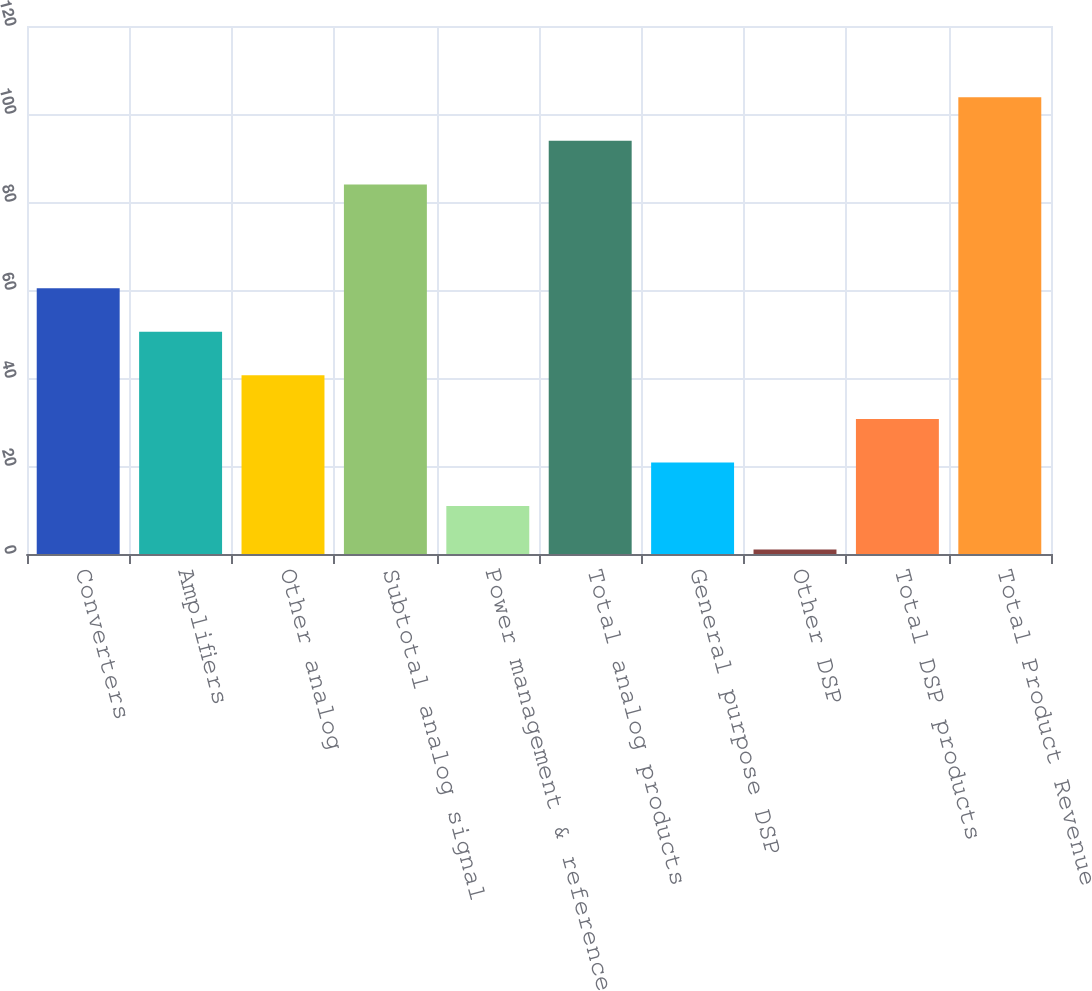Convert chart. <chart><loc_0><loc_0><loc_500><loc_500><bar_chart><fcel>Converters<fcel>Amplifiers<fcel>Other analog<fcel>Subtotal analog signal<fcel>Power management & reference<fcel>Total analog products<fcel>General purpose DSP<fcel>Other DSP<fcel>Total DSP products<fcel>Total Product Revenue<nl><fcel>60.4<fcel>50.5<fcel>40.6<fcel>84<fcel>10.9<fcel>93.9<fcel>20.8<fcel>1<fcel>30.7<fcel>103.8<nl></chart> 